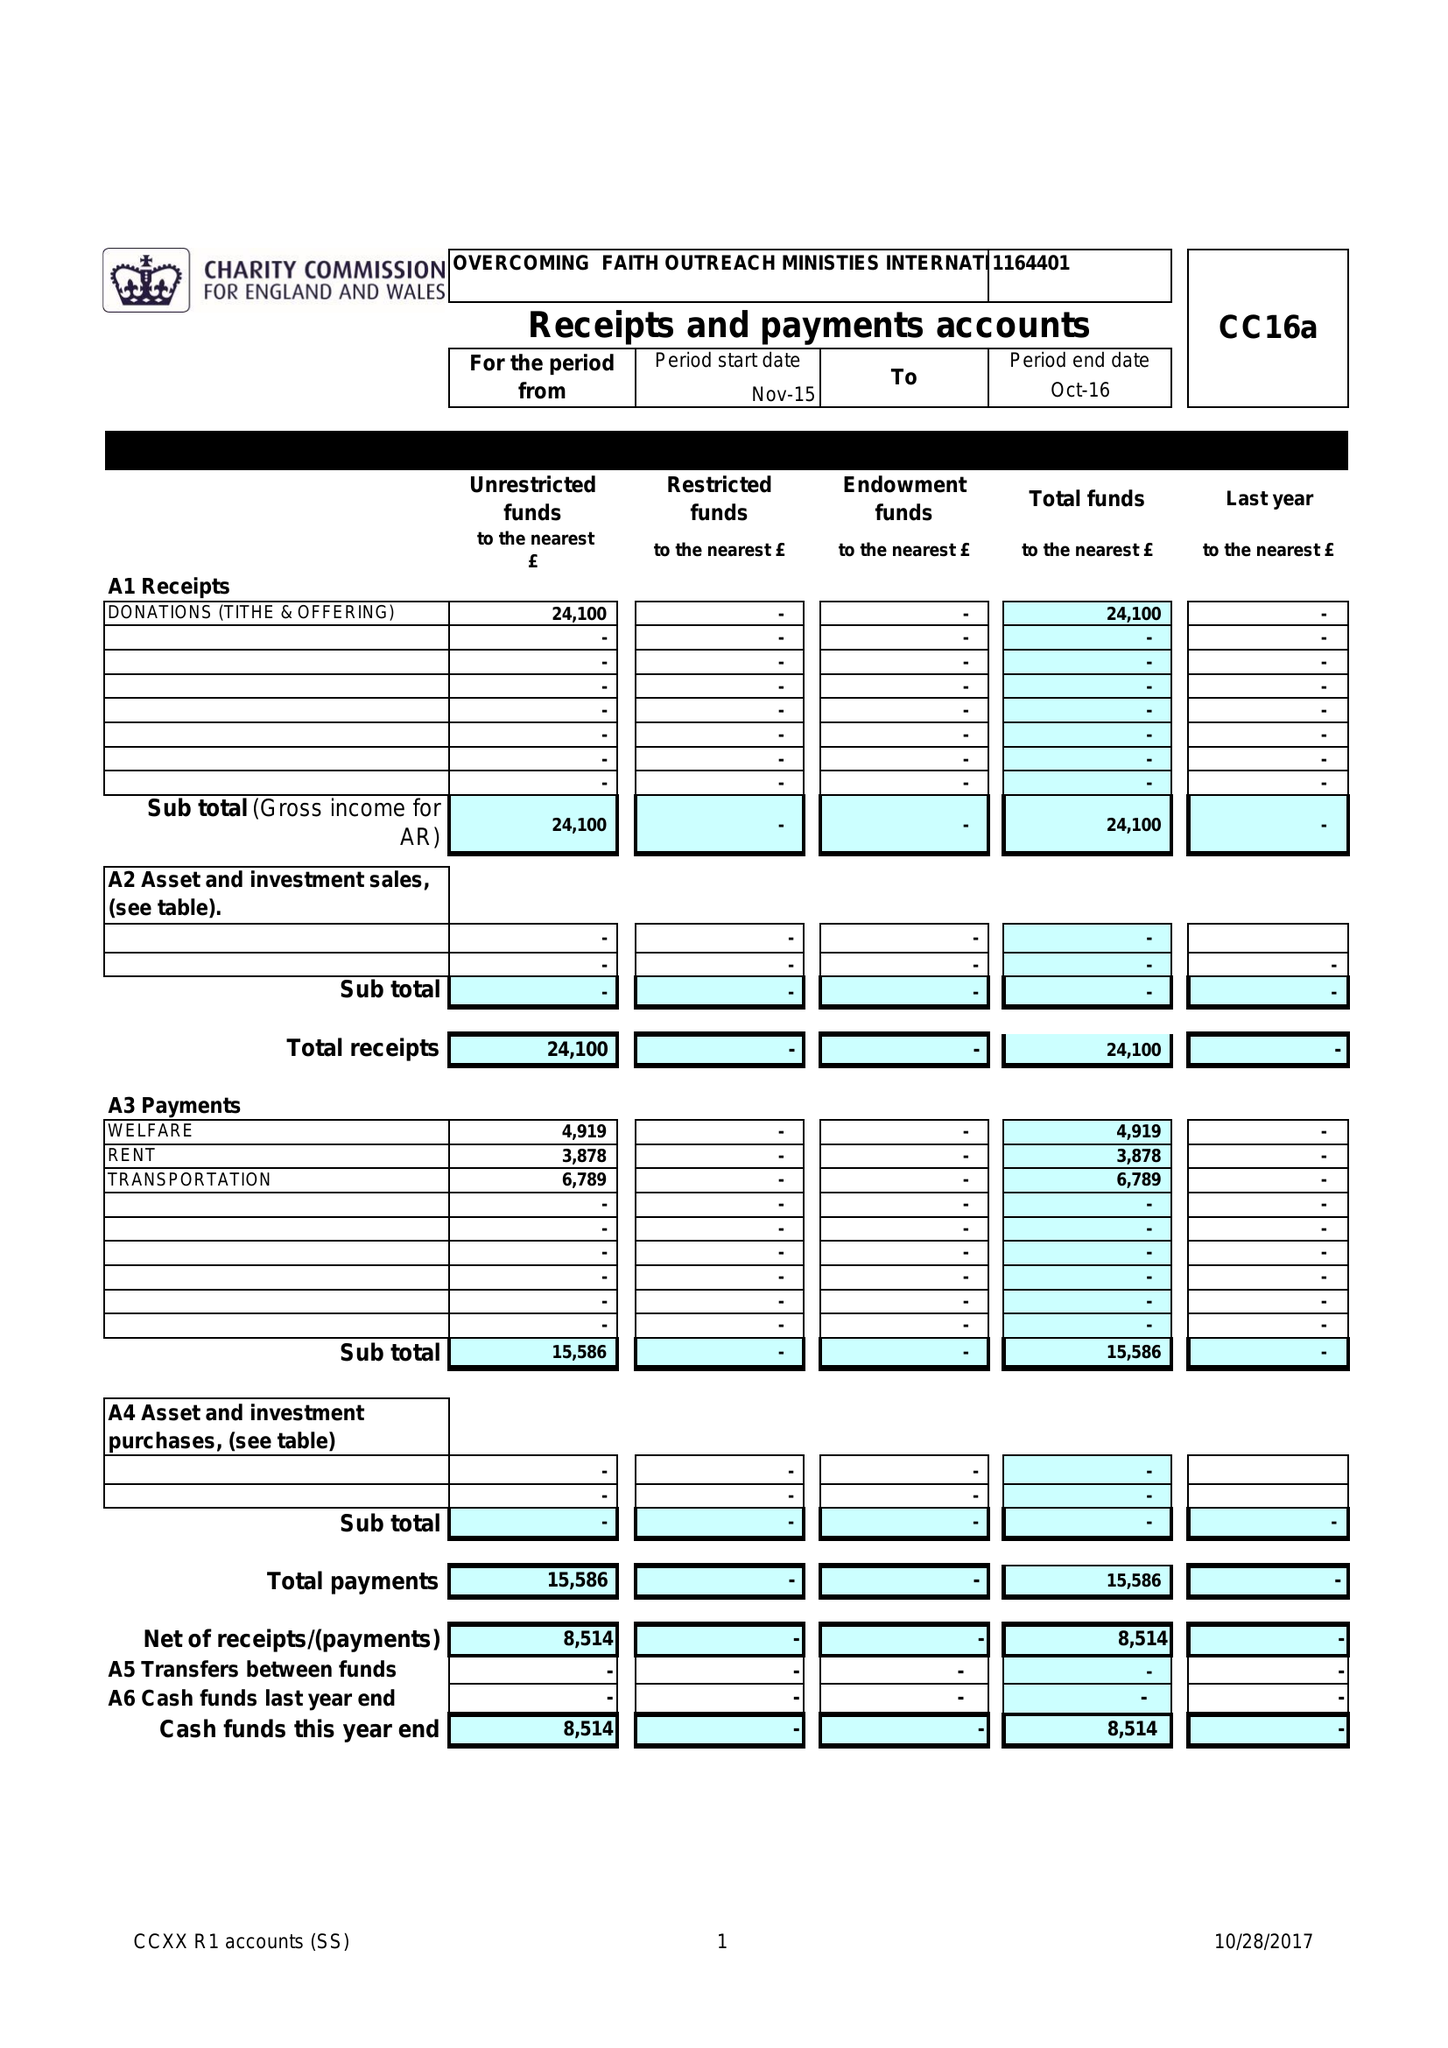What is the value for the spending_annually_in_british_pounds?
Answer the question using a single word or phrase. 15586.00 